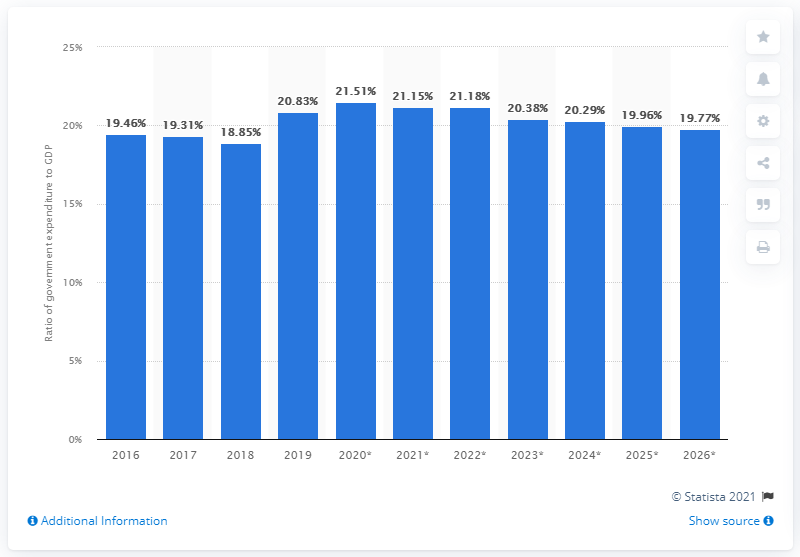What percentage of Sri Lanka's GDP did government expenditure amount to in 2019? In 2019, the government expenditure of Sri Lanka represented 20.83% of the country's Gross Domestic Product (GDP), as depicted in the provided bar chart. This indicates a marginally higher government spending ratio compared to the previous year, 2018, which was noted at 18.85% of the GDP. 